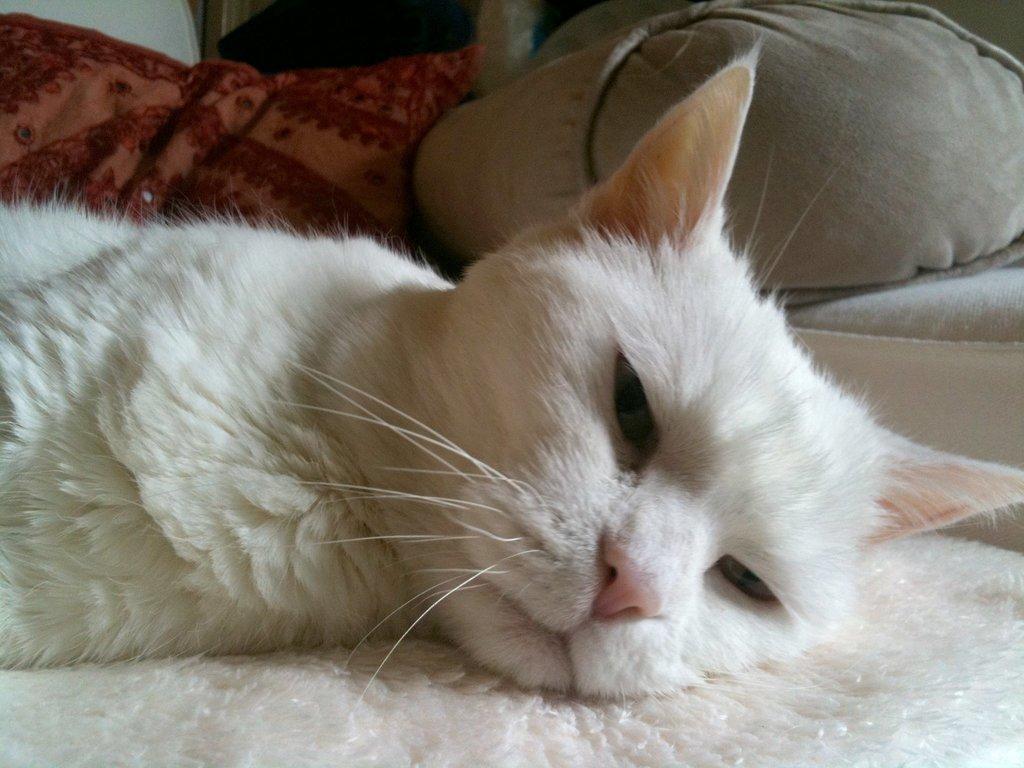Can you describe this image briefly? In this image, we can see a cat on the bed which is colored white. 